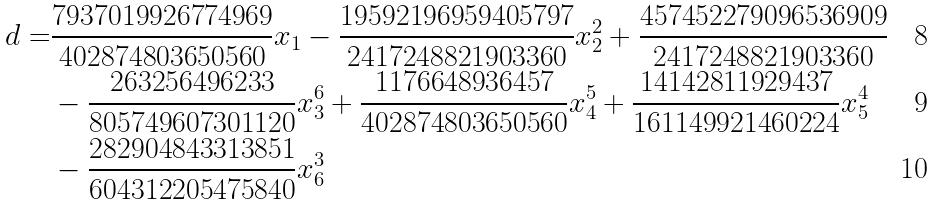<formula> <loc_0><loc_0><loc_500><loc_500>d = & \frac { 7 9 3 7 0 1 9 9 2 6 7 7 4 9 6 9 } { 4 0 2 8 7 4 8 0 3 6 5 0 5 6 0 } x _ { 1 } - \frac { 1 9 5 9 2 1 9 6 9 5 9 4 0 5 7 9 7 } { 2 4 1 7 2 4 8 8 2 1 9 0 3 3 6 0 } x _ { 2 } ^ { 2 } + \frac { 4 5 7 4 5 2 2 7 9 0 9 6 5 3 6 9 0 9 } { 2 4 1 7 2 4 8 8 2 1 9 0 3 3 6 0 } \\ & - \frac { 2 6 3 2 5 6 4 9 6 2 3 3 } { 8 0 5 7 4 9 6 0 7 3 0 1 1 2 0 } x _ { 3 } ^ { 6 } + \frac { 1 1 7 6 6 4 8 9 3 6 4 5 7 } { 4 0 2 8 7 4 8 0 3 6 5 0 5 6 0 } x _ { 4 } ^ { 5 } + \frac { 1 4 1 4 2 8 1 1 9 2 9 4 3 7 } { 1 6 1 1 4 9 9 2 1 4 6 0 2 2 4 } x _ { 5 } ^ { 4 } \\ & - \frac { 2 8 2 9 0 4 8 4 3 3 1 3 8 5 1 } { 6 0 4 3 1 2 2 0 5 4 7 5 8 4 0 } x _ { 6 } ^ { 3 }</formula> 